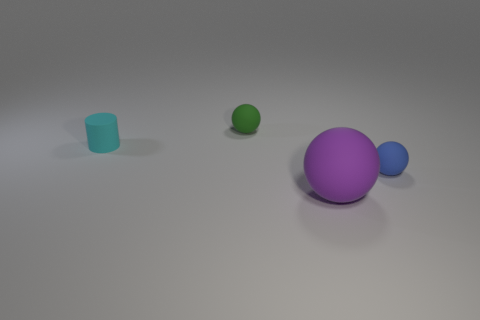Subtract all yellow cylinders. Subtract all brown cubes. How many cylinders are left? 1 Add 1 purple matte balls. How many objects exist? 5 Subtract all balls. How many objects are left? 1 Subtract all big purple rubber spheres. Subtract all large purple matte objects. How many objects are left? 2 Add 4 green matte balls. How many green matte balls are left? 5 Add 4 green matte objects. How many green matte objects exist? 5 Subtract 1 green balls. How many objects are left? 3 